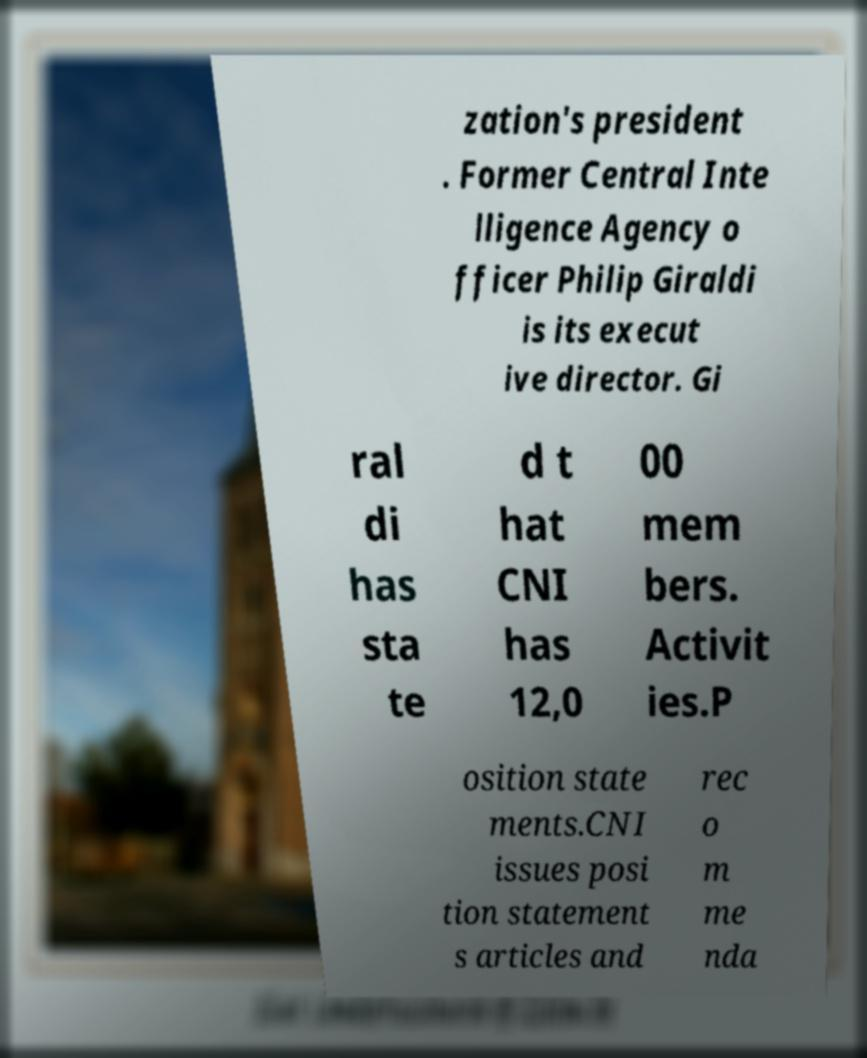Could you extract and type out the text from this image? zation's president . Former Central Inte lligence Agency o fficer Philip Giraldi is its execut ive director. Gi ral di has sta te d t hat CNI has 12,0 00 mem bers. Activit ies.P osition state ments.CNI issues posi tion statement s articles and rec o m me nda 